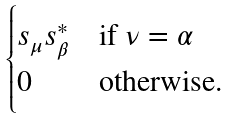<formula> <loc_0><loc_0><loc_500><loc_500>\begin{cases} s _ { \mu } s _ { \beta } ^ { * } & \text {if $\nu=\alpha$} \\ 0 & \text {otherwise.} \end{cases}</formula> 